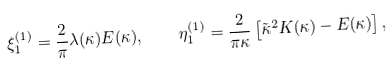<formula> <loc_0><loc_0><loc_500><loc_500>\xi _ { 1 } ^ { ( 1 ) } = \frac { 2 } { \pi } \lambda ( \kappa ) { E } ( \kappa ) , \quad \eta _ { 1 } ^ { ( 1 ) } = \frac { 2 } { \pi \kappa } \left [ \tilde { \kappa } ^ { 2 } { K } ( \kappa ) - { E } ( \kappa ) \right ] ,</formula> 